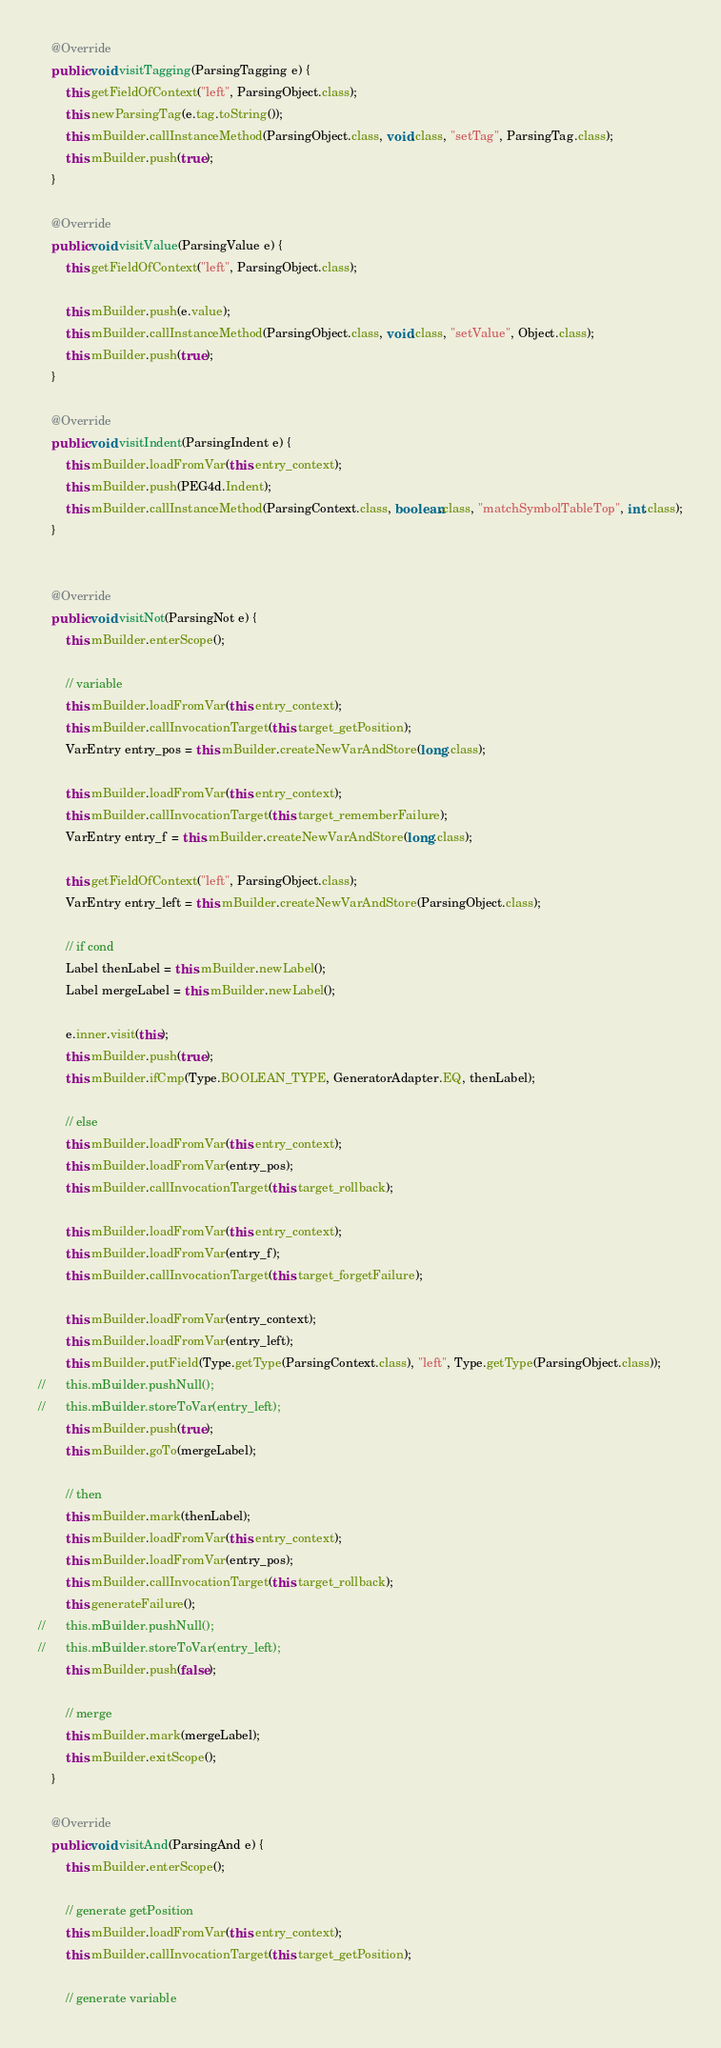Convert code to text. <code><loc_0><loc_0><loc_500><loc_500><_Java_>	@Override
	public void visitTagging(ParsingTagging e) {
		this.getFieldOfContext("left", ParsingObject.class);
		this.newParsingTag(e.tag.toString());
		this.mBuilder.callInstanceMethod(ParsingObject.class, void.class, "setTag", ParsingTag.class);
		this.mBuilder.push(true);
	}

	@Override
	public void visitValue(ParsingValue e) {
		this.getFieldOfContext("left", ParsingObject.class);

		this.mBuilder.push(e.value);
		this.mBuilder.callInstanceMethod(ParsingObject.class, void.class, "setValue", Object.class);
		this.mBuilder.push(true);
	}

	@Override
	public void visitIndent(ParsingIndent e) {
		this.mBuilder.loadFromVar(this.entry_context);
		this.mBuilder.push(PEG4d.Indent);
		this.mBuilder.callInstanceMethod(ParsingContext.class, boolean.class, "matchSymbolTableTop", int.class);
	}


	@Override
	public void visitNot(ParsingNot e) {
		this.mBuilder.enterScope();

		// variable
		this.mBuilder.loadFromVar(this.entry_context);
		this.mBuilder.callInvocationTarget(this.target_getPosition);
		VarEntry entry_pos = this.mBuilder.createNewVarAndStore(long.class);

		this.mBuilder.loadFromVar(this.entry_context);
		this.mBuilder.callInvocationTarget(this.target_rememberFailure);
		VarEntry entry_f = this.mBuilder.createNewVarAndStore(long.class);

		this.getFieldOfContext("left", ParsingObject.class);
		VarEntry entry_left = this.mBuilder.createNewVarAndStore(ParsingObject.class);

		// if cond
		Label thenLabel = this.mBuilder.newLabel();
		Label mergeLabel = this.mBuilder.newLabel();

		e.inner.visit(this);
		this.mBuilder.push(true);
		this.mBuilder.ifCmp(Type.BOOLEAN_TYPE, GeneratorAdapter.EQ, thenLabel);

		// else
		this.mBuilder.loadFromVar(this.entry_context);
		this.mBuilder.loadFromVar(entry_pos);
		this.mBuilder.callInvocationTarget(this.target_rollback);

		this.mBuilder.loadFromVar(this.entry_context);
		this.mBuilder.loadFromVar(entry_f);
		this.mBuilder.callInvocationTarget(this.target_forgetFailure);

		this.mBuilder.loadFromVar(entry_context);
		this.mBuilder.loadFromVar(entry_left);
		this.mBuilder.putField(Type.getType(ParsingContext.class), "left", Type.getType(ParsingObject.class));
//		this.mBuilder.pushNull();
//		this.mBuilder.storeToVar(entry_left);
		this.mBuilder.push(true);
		this.mBuilder.goTo(mergeLabel);

		// then
		this.mBuilder.mark(thenLabel);
		this.mBuilder.loadFromVar(this.entry_context);
		this.mBuilder.loadFromVar(entry_pos);
		this.mBuilder.callInvocationTarget(this.target_rollback);
		this.generateFailure();
//		this.mBuilder.pushNull();
//		this.mBuilder.storeToVar(entry_left);
		this.mBuilder.push(false);

		// merge
		this.mBuilder.mark(mergeLabel);
		this.mBuilder.exitScope();
	}

	@Override
	public void visitAnd(ParsingAnd e) {
		this.mBuilder.enterScope();

		// generate getPosition
		this.mBuilder.loadFromVar(this.entry_context);
		this.mBuilder.callInvocationTarget(this.target_getPosition);

		// generate variable</code> 